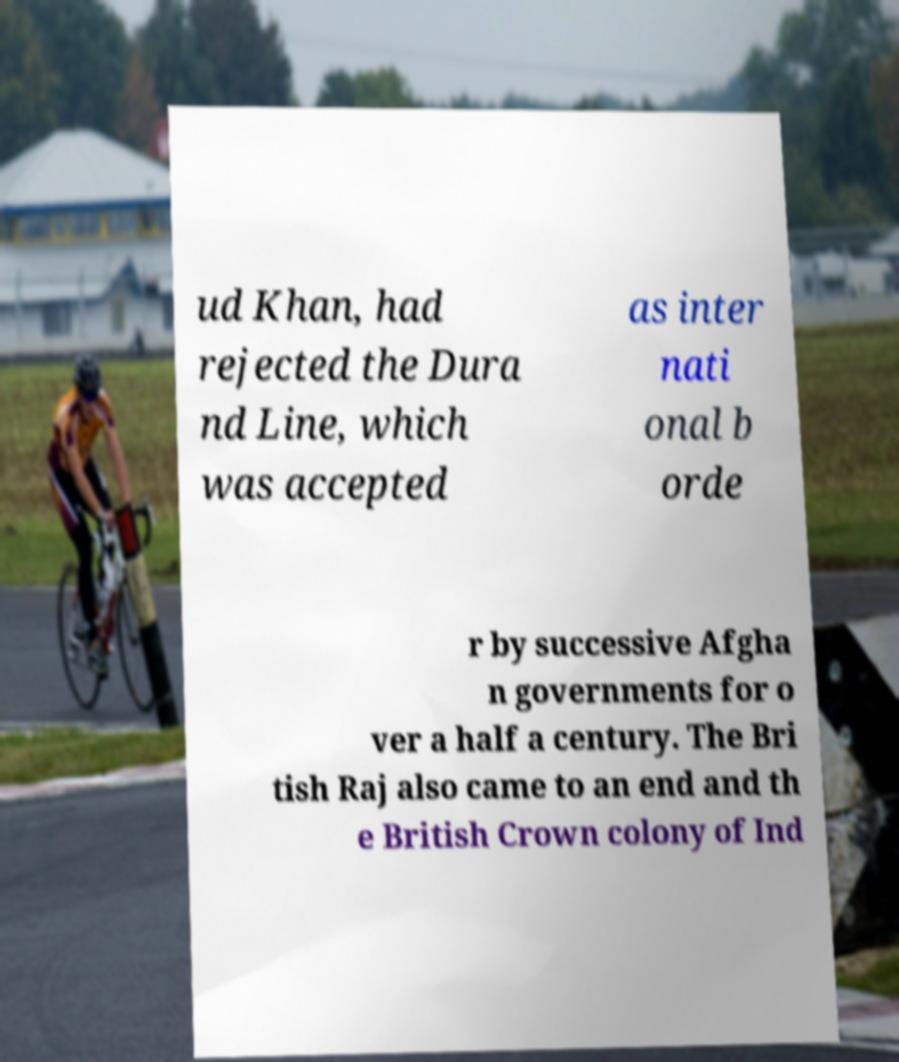Please read and relay the text visible in this image. What does it say? ud Khan, had rejected the Dura nd Line, which was accepted as inter nati onal b orde r by successive Afgha n governments for o ver a half a century. The Bri tish Raj also came to an end and th e British Crown colony of Ind 